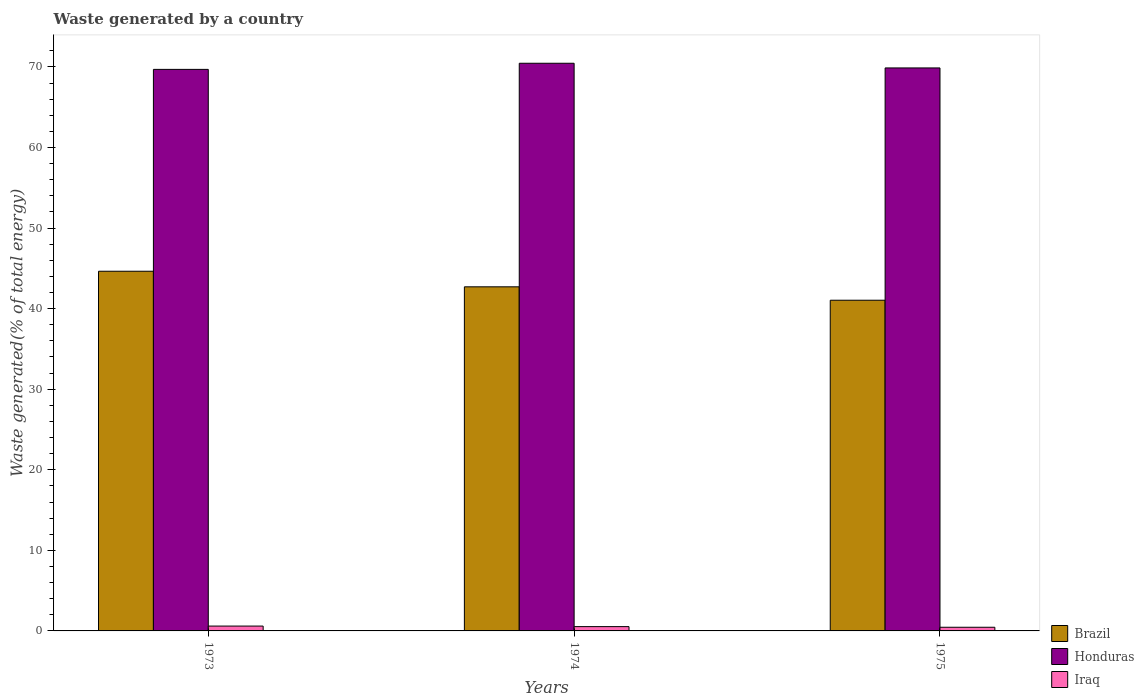How many groups of bars are there?
Keep it short and to the point. 3. Are the number of bars per tick equal to the number of legend labels?
Your response must be concise. Yes. How many bars are there on the 3rd tick from the left?
Keep it short and to the point. 3. In how many cases, is the number of bars for a given year not equal to the number of legend labels?
Offer a terse response. 0. What is the total waste generated in Brazil in 1973?
Your answer should be compact. 44.64. Across all years, what is the maximum total waste generated in Iraq?
Offer a very short reply. 0.6. Across all years, what is the minimum total waste generated in Brazil?
Your answer should be very brief. 41.04. In which year was the total waste generated in Iraq minimum?
Make the answer very short. 1975. What is the total total waste generated in Brazil in the graph?
Keep it short and to the point. 128.39. What is the difference between the total waste generated in Brazil in 1973 and that in 1974?
Offer a very short reply. 1.93. What is the difference between the total waste generated in Brazil in 1975 and the total waste generated in Iraq in 1973?
Your answer should be very brief. 40.44. What is the average total waste generated in Iraq per year?
Your answer should be compact. 0.53. In the year 1975, what is the difference between the total waste generated in Honduras and total waste generated in Brazil?
Ensure brevity in your answer.  28.83. In how many years, is the total waste generated in Iraq greater than 34 %?
Give a very brief answer. 0. What is the ratio of the total waste generated in Iraq in 1974 to that in 1975?
Provide a succinct answer. 1.17. Is the total waste generated in Honduras in 1973 less than that in 1975?
Make the answer very short. Yes. What is the difference between the highest and the second highest total waste generated in Iraq?
Make the answer very short. 0.07. What is the difference between the highest and the lowest total waste generated in Brazil?
Your response must be concise. 3.6. Is the sum of the total waste generated in Iraq in 1974 and 1975 greater than the maximum total waste generated in Honduras across all years?
Offer a very short reply. No. What does the 3rd bar from the left in 1973 represents?
Provide a short and direct response. Iraq. What does the 2nd bar from the right in 1973 represents?
Your response must be concise. Honduras. Is it the case that in every year, the sum of the total waste generated in Honduras and total waste generated in Iraq is greater than the total waste generated in Brazil?
Offer a terse response. Yes. How many bars are there?
Your answer should be compact. 9. How many years are there in the graph?
Ensure brevity in your answer.  3. Are the values on the major ticks of Y-axis written in scientific E-notation?
Offer a very short reply. No. How many legend labels are there?
Your response must be concise. 3. What is the title of the graph?
Your answer should be very brief. Waste generated by a country. What is the label or title of the X-axis?
Provide a short and direct response. Years. What is the label or title of the Y-axis?
Provide a short and direct response. Waste generated(% of total energy). What is the Waste generated(% of total energy) in Brazil in 1973?
Provide a short and direct response. 44.64. What is the Waste generated(% of total energy) of Honduras in 1973?
Keep it short and to the point. 69.69. What is the Waste generated(% of total energy) in Iraq in 1973?
Ensure brevity in your answer.  0.6. What is the Waste generated(% of total energy) of Brazil in 1974?
Provide a short and direct response. 42.71. What is the Waste generated(% of total energy) of Honduras in 1974?
Provide a short and direct response. 70.45. What is the Waste generated(% of total energy) of Iraq in 1974?
Give a very brief answer. 0.53. What is the Waste generated(% of total energy) of Brazil in 1975?
Your answer should be compact. 41.04. What is the Waste generated(% of total energy) in Honduras in 1975?
Provide a short and direct response. 69.87. What is the Waste generated(% of total energy) of Iraq in 1975?
Provide a short and direct response. 0.45. Across all years, what is the maximum Waste generated(% of total energy) of Brazil?
Provide a short and direct response. 44.64. Across all years, what is the maximum Waste generated(% of total energy) in Honduras?
Ensure brevity in your answer.  70.45. Across all years, what is the maximum Waste generated(% of total energy) in Iraq?
Provide a short and direct response. 0.6. Across all years, what is the minimum Waste generated(% of total energy) in Brazil?
Give a very brief answer. 41.04. Across all years, what is the minimum Waste generated(% of total energy) of Honduras?
Keep it short and to the point. 69.69. Across all years, what is the minimum Waste generated(% of total energy) of Iraq?
Give a very brief answer. 0.45. What is the total Waste generated(% of total energy) in Brazil in the graph?
Keep it short and to the point. 128.39. What is the total Waste generated(% of total energy) in Honduras in the graph?
Ensure brevity in your answer.  210.01. What is the total Waste generated(% of total energy) in Iraq in the graph?
Provide a succinct answer. 1.59. What is the difference between the Waste generated(% of total energy) of Brazil in 1973 and that in 1974?
Give a very brief answer. 1.93. What is the difference between the Waste generated(% of total energy) in Honduras in 1973 and that in 1974?
Keep it short and to the point. -0.76. What is the difference between the Waste generated(% of total energy) in Iraq in 1973 and that in 1974?
Provide a succinct answer. 0.07. What is the difference between the Waste generated(% of total energy) of Brazil in 1973 and that in 1975?
Offer a very short reply. 3.6. What is the difference between the Waste generated(% of total energy) in Honduras in 1973 and that in 1975?
Give a very brief answer. -0.18. What is the difference between the Waste generated(% of total energy) of Iraq in 1973 and that in 1975?
Keep it short and to the point. 0.15. What is the difference between the Waste generated(% of total energy) in Brazil in 1974 and that in 1975?
Keep it short and to the point. 1.66. What is the difference between the Waste generated(% of total energy) of Honduras in 1974 and that in 1975?
Your answer should be very brief. 0.58. What is the difference between the Waste generated(% of total energy) in Iraq in 1974 and that in 1975?
Your response must be concise. 0.08. What is the difference between the Waste generated(% of total energy) of Brazil in 1973 and the Waste generated(% of total energy) of Honduras in 1974?
Your answer should be very brief. -25.81. What is the difference between the Waste generated(% of total energy) of Brazil in 1973 and the Waste generated(% of total energy) of Iraq in 1974?
Provide a short and direct response. 44.11. What is the difference between the Waste generated(% of total energy) in Honduras in 1973 and the Waste generated(% of total energy) in Iraq in 1974?
Make the answer very short. 69.16. What is the difference between the Waste generated(% of total energy) of Brazil in 1973 and the Waste generated(% of total energy) of Honduras in 1975?
Your response must be concise. -25.23. What is the difference between the Waste generated(% of total energy) in Brazil in 1973 and the Waste generated(% of total energy) in Iraq in 1975?
Offer a terse response. 44.18. What is the difference between the Waste generated(% of total energy) of Honduras in 1973 and the Waste generated(% of total energy) of Iraq in 1975?
Provide a short and direct response. 69.24. What is the difference between the Waste generated(% of total energy) of Brazil in 1974 and the Waste generated(% of total energy) of Honduras in 1975?
Offer a terse response. -27.16. What is the difference between the Waste generated(% of total energy) in Brazil in 1974 and the Waste generated(% of total energy) in Iraq in 1975?
Provide a succinct answer. 42.25. What is the difference between the Waste generated(% of total energy) in Honduras in 1974 and the Waste generated(% of total energy) in Iraq in 1975?
Your response must be concise. 70. What is the average Waste generated(% of total energy) of Brazil per year?
Offer a very short reply. 42.8. What is the average Waste generated(% of total energy) in Honduras per year?
Your answer should be compact. 70. What is the average Waste generated(% of total energy) in Iraq per year?
Offer a terse response. 0.53. In the year 1973, what is the difference between the Waste generated(% of total energy) in Brazil and Waste generated(% of total energy) in Honduras?
Your answer should be compact. -25.05. In the year 1973, what is the difference between the Waste generated(% of total energy) in Brazil and Waste generated(% of total energy) in Iraq?
Provide a short and direct response. 44.04. In the year 1973, what is the difference between the Waste generated(% of total energy) of Honduras and Waste generated(% of total energy) of Iraq?
Your answer should be compact. 69.09. In the year 1974, what is the difference between the Waste generated(% of total energy) of Brazil and Waste generated(% of total energy) of Honduras?
Your answer should be compact. -27.75. In the year 1974, what is the difference between the Waste generated(% of total energy) in Brazil and Waste generated(% of total energy) in Iraq?
Your response must be concise. 42.17. In the year 1974, what is the difference between the Waste generated(% of total energy) in Honduras and Waste generated(% of total energy) in Iraq?
Your answer should be compact. 69.92. In the year 1975, what is the difference between the Waste generated(% of total energy) in Brazil and Waste generated(% of total energy) in Honduras?
Your answer should be compact. -28.83. In the year 1975, what is the difference between the Waste generated(% of total energy) in Brazil and Waste generated(% of total energy) in Iraq?
Your response must be concise. 40.59. In the year 1975, what is the difference between the Waste generated(% of total energy) of Honduras and Waste generated(% of total energy) of Iraq?
Ensure brevity in your answer.  69.42. What is the ratio of the Waste generated(% of total energy) in Brazil in 1973 to that in 1974?
Provide a succinct answer. 1.05. What is the ratio of the Waste generated(% of total energy) in Honduras in 1973 to that in 1974?
Keep it short and to the point. 0.99. What is the ratio of the Waste generated(% of total energy) of Iraq in 1973 to that in 1974?
Offer a terse response. 1.13. What is the ratio of the Waste generated(% of total energy) in Brazil in 1973 to that in 1975?
Ensure brevity in your answer.  1.09. What is the ratio of the Waste generated(% of total energy) in Honduras in 1973 to that in 1975?
Keep it short and to the point. 1. What is the ratio of the Waste generated(% of total energy) of Iraq in 1973 to that in 1975?
Your response must be concise. 1.33. What is the ratio of the Waste generated(% of total energy) in Brazil in 1974 to that in 1975?
Provide a short and direct response. 1.04. What is the ratio of the Waste generated(% of total energy) of Honduras in 1974 to that in 1975?
Offer a very short reply. 1.01. What is the ratio of the Waste generated(% of total energy) in Iraq in 1974 to that in 1975?
Give a very brief answer. 1.17. What is the difference between the highest and the second highest Waste generated(% of total energy) in Brazil?
Your answer should be compact. 1.93. What is the difference between the highest and the second highest Waste generated(% of total energy) in Honduras?
Your response must be concise. 0.58. What is the difference between the highest and the second highest Waste generated(% of total energy) in Iraq?
Provide a short and direct response. 0.07. What is the difference between the highest and the lowest Waste generated(% of total energy) in Brazil?
Keep it short and to the point. 3.6. What is the difference between the highest and the lowest Waste generated(% of total energy) in Honduras?
Provide a succinct answer. 0.76. What is the difference between the highest and the lowest Waste generated(% of total energy) of Iraq?
Offer a terse response. 0.15. 